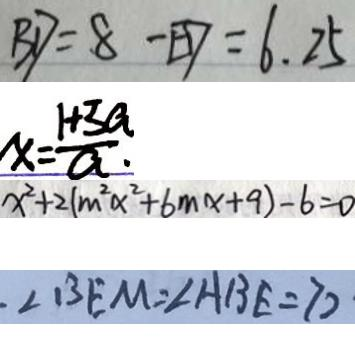Convert formula to latex. <formula><loc_0><loc_0><loc_500><loc_500>B D = 8 - E D = 6 . 2 5 
 x = \frac { 1 + 3 a } { a } . 
 x ^ { 2 } + 2 ( m ^ { 2 } x ^ { 2 } + 6 m x + 9 ) - 6 = 0 
 \angle B E M = \angle A B E = 7 0</formula> 